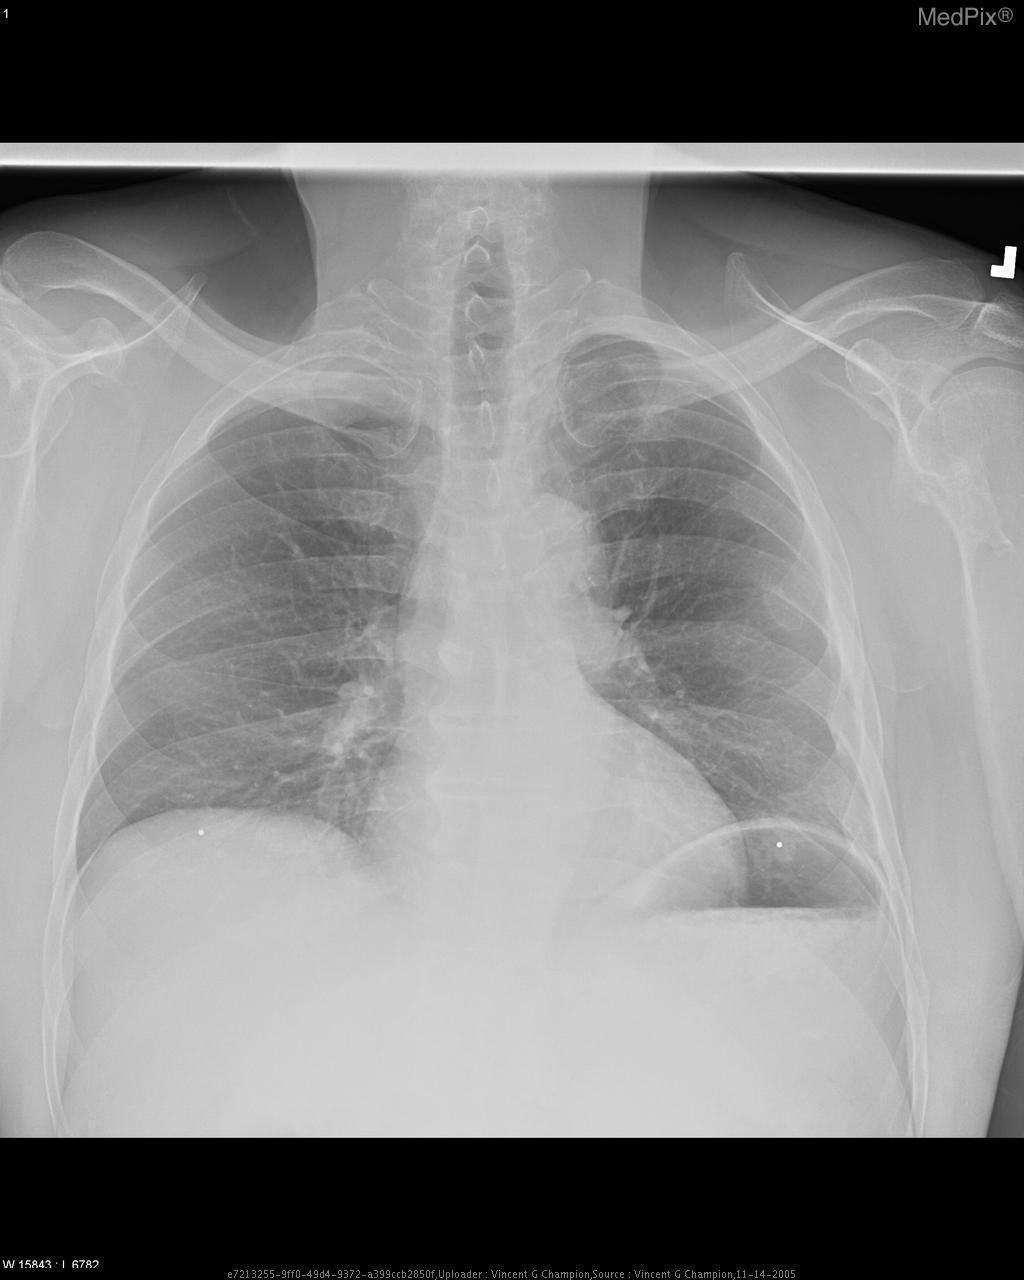Does this patient have cardiomegaly?
Write a very short answer. No. What type of imaging modality is this?
Write a very short answer. Xray - plain film. Is there a clavicle fracture shown in this radiograph?
Short answer required. No. 